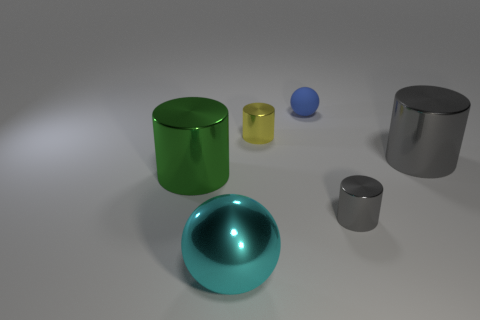What shape is the tiny object that is both behind the large green shiny cylinder and in front of the blue matte ball?
Offer a very short reply. Cylinder. The sphere that is made of the same material as the big green cylinder is what color?
Give a very brief answer. Cyan. The gray metal thing in front of the cylinder right of the gray shiny cylinder that is on the left side of the large gray shiny object is what shape?
Give a very brief answer. Cylinder. The cyan metallic object is what size?
Give a very brief answer. Large. There is a large gray thing that is the same material as the large sphere; what is its shape?
Make the answer very short. Cylinder. Is the number of balls behind the tiny yellow metallic thing less than the number of metallic balls?
Give a very brief answer. No. There is a small cylinder on the left side of the blue object; what color is it?
Provide a succinct answer. Yellow. Is there another rubber object that has the same shape as the tiny matte object?
Your answer should be compact. No. How many large red things are the same shape as the tiny gray metallic object?
Keep it short and to the point. 0. Is the number of purple shiny cylinders less than the number of spheres?
Give a very brief answer. Yes. 